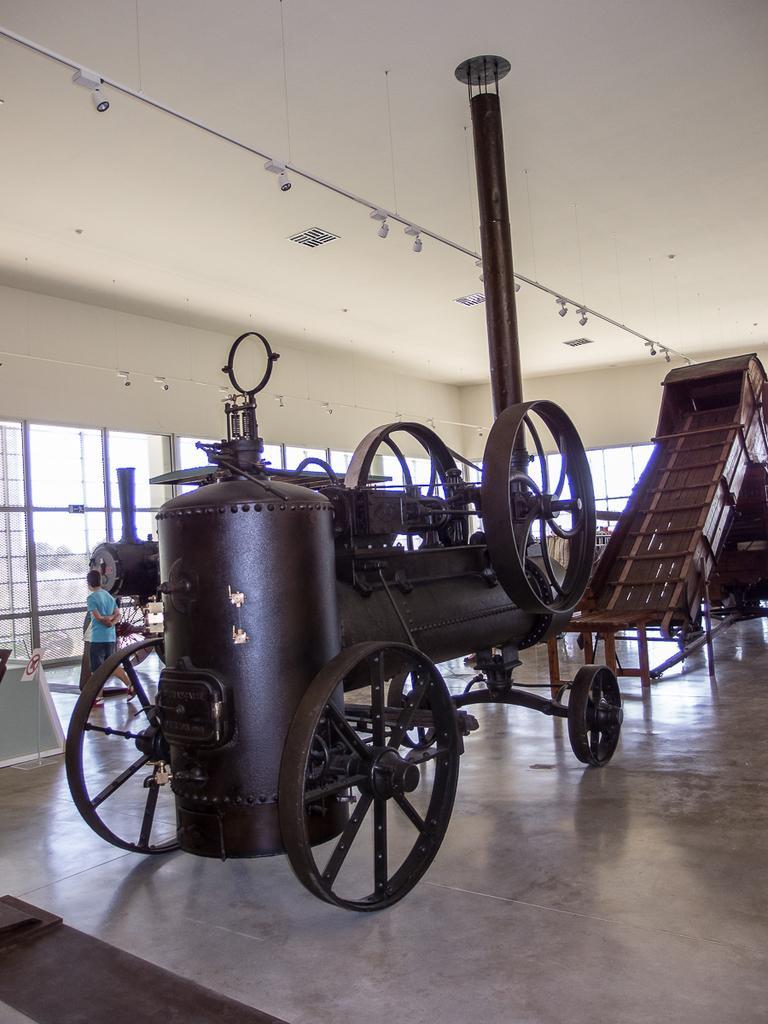Could you give a brief overview of what you see in this image? In this image we can see a vehicle with wheels and a cylinder. Also there is a pole. In the back there are glass windows. On the ceiling there are lights. Also we can see a person in the back. 